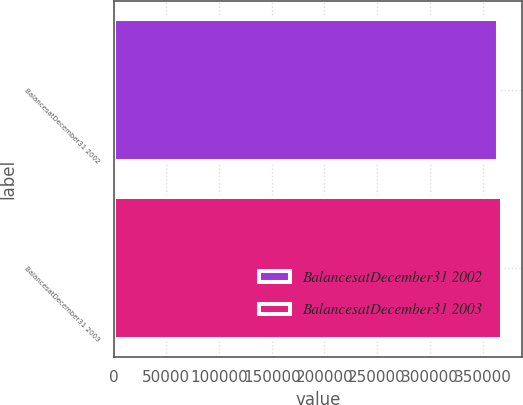<chart> <loc_0><loc_0><loc_500><loc_500><bar_chart><fcel>BalancesatDecember31 2002<fcel>BalancesatDecember31 2003<nl><fcel>364691<fcel>368796<nl></chart> 